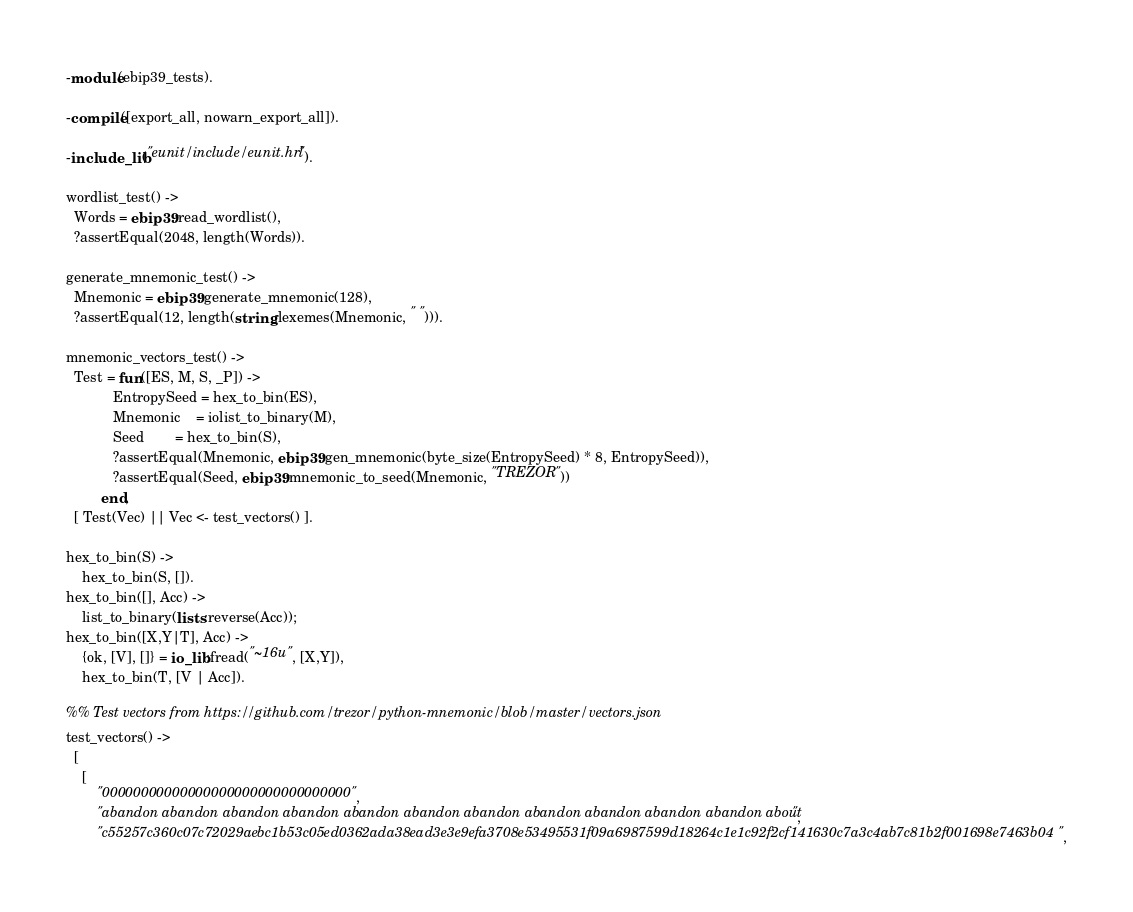<code> <loc_0><loc_0><loc_500><loc_500><_Erlang_>-module(ebip39_tests).

-compile([export_all, nowarn_export_all]).

-include_lib("eunit/include/eunit.hrl").

wordlist_test() ->
  Words = ebip39:read_wordlist(),
  ?assertEqual(2048, length(Words)).

generate_mnemonic_test() ->
  Mnemonic = ebip39:generate_mnemonic(128),
  ?assertEqual(12, length(string:lexemes(Mnemonic, " "))).

mnemonic_vectors_test() ->
  Test = fun([ES, M, S, _P]) ->
            EntropySeed = hex_to_bin(ES),
            Mnemonic    = iolist_to_binary(M),
            Seed        = hex_to_bin(S),
            ?assertEqual(Mnemonic, ebip39:gen_mnemonic(byte_size(EntropySeed) * 8, EntropySeed)),
            ?assertEqual(Seed, ebip39:mnemonic_to_seed(Mnemonic, "TREZOR"))
         end,
  [ Test(Vec) || Vec <- test_vectors() ].

hex_to_bin(S) ->
    hex_to_bin(S, []).
hex_to_bin([], Acc) ->
    list_to_binary(lists:reverse(Acc));
hex_to_bin([X,Y|T], Acc) ->
    {ok, [V], []} = io_lib:fread("~16u", [X,Y]),
    hex_to_bin(T, [V | Acc]).

%% Test vectors from https://github.com/trezor/python-mnemonic/blob/master/vectors.json
test_vectors() ->
  [
    [
        "00000000000000000000000000000000",
        "abandon abandon abandon abandon abandon abandon abandon abandon abandon abandon abandon about",
        "c55257c360c07c72029aebc1b53c05ed0362ada38ead3e3e9efa3708e53495531f09a6987599d18264c1e1c92f2cf141630c7a3c4ab7c81b2f001698e7463b04",</code> 